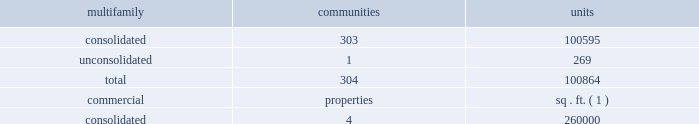2022 level and volatility of interest or capitalization rates or capital market conditions ; 2022 loss of hedge accounting treatment for interest rate swaps ; 2022 the continuation of the good credit of our interest rate swap providers ; 2022 price volatility , dislocations and liquidity disruptions in the financial markets and the resulting impact on financing ; 2022 the effect of any rating agency actions on the cost and availability of new debt financing ; 2022 significant decline in market value of real estate serving as collateral for mortgage obligations ; 2022 significant change in the mortgage financing market that would cause single-family housing , either as an owned or rental product , to become a more significant competitive product ; 2022 our ability to continue to satisfy complex rules in order to maintain our status as a reit for federal income tax purposes , the ability of the operating partnership to satisfy the rules to maintain its status as a partnership for federal income tax purposes , the ability of our taxable reit subsidiaries to maintain their status as such for federal income tax purposes , and our ability and the ability of our subsidiaries to operate effectively within the limitations imposed by these rules ; 2022 inability to attract and retain qualified personnel ; 2022 cyber liability or potential liability for breaches of our privacy or information security systems ; 2022 potential liability for environmental contamination ; 2022 adverse legislative or regulatory tax changes ; 2022 legal proceedings relating to various issues , which , among other things , could result in a class action lawsuit ; 2022 compliance costs associated with laws requiring access for disabled persons ; and 2022 other risks identified in this annual report on form 10-k including under the caption "item 1a .
Risk factors" and , from time to time , in other reports we file with the securities and exchange commission , or the sec , or in other documents that we publicly disseminate .
New factors may also emerge from time to time that could have a material adverse effect on our business .
Except as required by law , we undertake no obligation to publicly update or revise forward-looking statements contained in this annual report on form 10-k to reflect events , circumstances or changes in expectations after the date on which this annual report on form 10-k is filed .
Item 1 .
Business .
Overview maa is a multifamily focused , self-administered and self-managed real estate investment trust , or reit .
We own , operate , acquire and selectively develop apartment communities located in the southeast , southwest and mid-atlantic regions of the united states .
As of december 31 , 2018 , we maintained full or partial ownership of apartment communities and commercial properties across 17 states and the district of columbia , summarized as follows: .
( 1 ) excludes commercial space located at our multifamily apartment communities , which totals approximately 615000 square feet of gross leasable space .
Our business is conducted principally through the operating partnership .
Maa is the sole general partner of the operating partnership , holding 113844267 op units , comprising a 96.5% ( 96.5 % ) partnership interest in the operating partnership as of december 31 , 2018 .
Maa and maalp were formed in tennessee in 1993 .
As of december 31 , 2018 , we had 2508 full- time employees and 44 part-time employees. .
What is the percentage of unconsolidated units among the total units? 
Rationale: it is the number of unconsolidated units divided by the total units , then turned into a percentage .
Computations: (269 / 100864)
Answer: 0.00267. 2022 level and volatility of interest or capitalization rates or capital market conditions ; 2022 loss of hedge accounting treatment for interest rate swaps ; 2022 the continuation of the good credit of our interest rate swap providers ; 2022 price volatility , dislocations and liquidity disruptions in the financial markets and the resulting impact on financing ; 2022 the effect of any rating agency actions on the cost and availability of new debt financing ; 2022 significant decline in market value of real estate serving as collateral for mortgage obligations ; 2022 significant change in the mortgage financing market that would cause single-family housing , either as an owned or rental product , to become a more significant competitive product ; 2022 our ability to continue to satisfy complex rules in order to maintain our status as a reit for federal income tax purposes , the ability of the operating partnership to satisfy the rules to maintain its status as a partnership for federal income tax purposes , the ability of our taxable reit subsidiaries to maintain their status as such for federal income tax purposes , and our ability and the ability of our subsidiaries to operate effectively within the limitations imposed by these rules ; 2022 inability to attract and retain qualified personnel ; 2022 cyber liability or potential liability for breaches of our privacy or information security systems ; 2022 potential liability for environmental contamination ; 2022 adverse legislative or regulatory tax changes ; 2022 legal proceedings relating to various issues , which , among other things , could result in a class action lawsuit ; 2022 compliance costs associated with laws requiring access for disabled persons ; and 2022 other risks identified in this annual report on form 10-k including under the caption "item 1a .
Risk factors" and , from time to time , in other reports we file with the securities and exchange commission , or the sec , or in other documents that we publicly disseminate .
New factors may also emerge from time to time that could have a material adverse effect on our business .
Except as required by law , we undertake no obligation to publicly update or revise forward-looking statements contained in this annual report on form 10-k to reflect events , circumstances or changes in expectations after the date on which this annual report on form 10-k is filed .
Item 1 .
Business .
Overview maa is a multifamily focused , self-administered and self-managed real estate investment trust , or reit .
We own , operate , acquire and selectively develop apartment communities located in the southeast , southwest and mid-atlantic regions of the united states .
As of december 31 , 2018 , we maintained full or partial ownership of apartment communities and commercial properties across 17 states and the district of columbia , summarized as follows: .
( 1 ) excludes commercial space located at our multifamily apartment communities , which totals approximately 615000 square feet of gross leasable space .
Our business is conducted principally through the operating partnership .
Maa is the sole general partner of the operating partnership , holding 113844267 op units , comprising a 96.5% ( 96.5 % ) partnership interest in the operating partnership as of december 31 , 2018 .
Maa and maalp were formed in tennessee in 1993 .
As of december 31 , 2018 , we had 2508 full- time employees and 44 part-time employees. .
As of december 2018 what was the ratio of the commercial units to multi family consolidated units? 
Rationale: as of december 2018 there was 2.59 commercial units for each multi family consolidated units
Computations: (260000 / 100595)
Answer: 2.58462. 